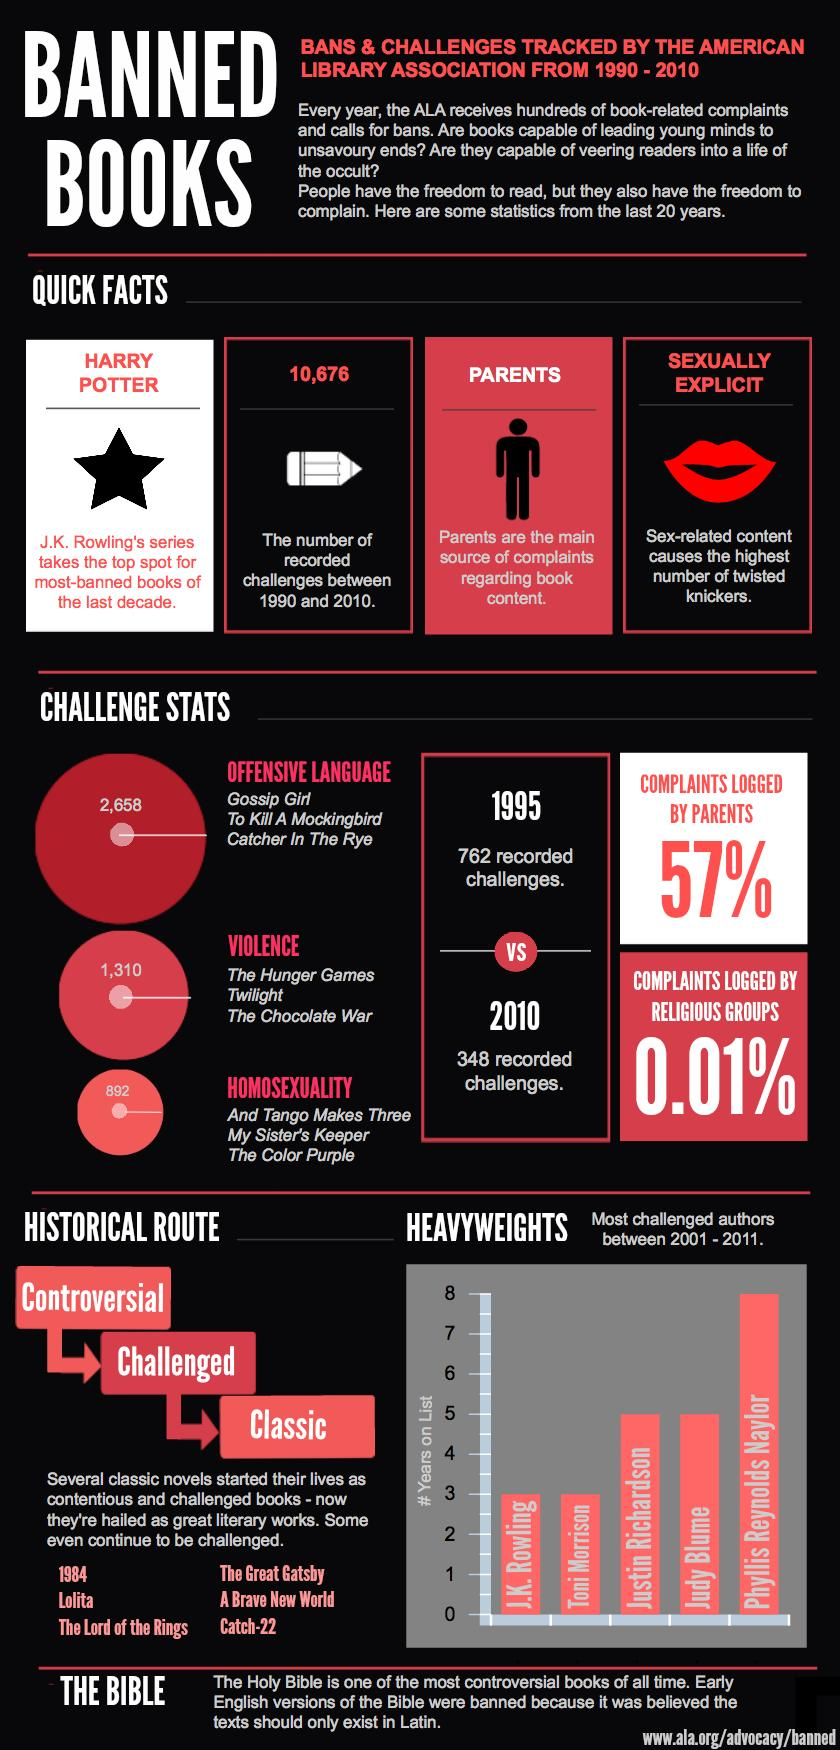Indicate a few pertinent items in this graphic. Phyllis Reynolds Naylor was the most challenged author between 2001 and 2011. The book "The Color Purple" was challenged because of its depiction of homosexuality. There have been a recorded total of 10,676 challenges between 1990 and 2010. The book 'Gossip Girl' recorded a total of 2,658 challenges. The book 'The Hunger Games' was challenged due to its violent content. 